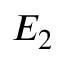<formula> <loc_0><loc_0><loc_500><loc_500>E _ { 2 }</formula> 